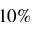<formula> <loc_0><loc_0><loc_500><loc_500>1 0 \%</formula> 